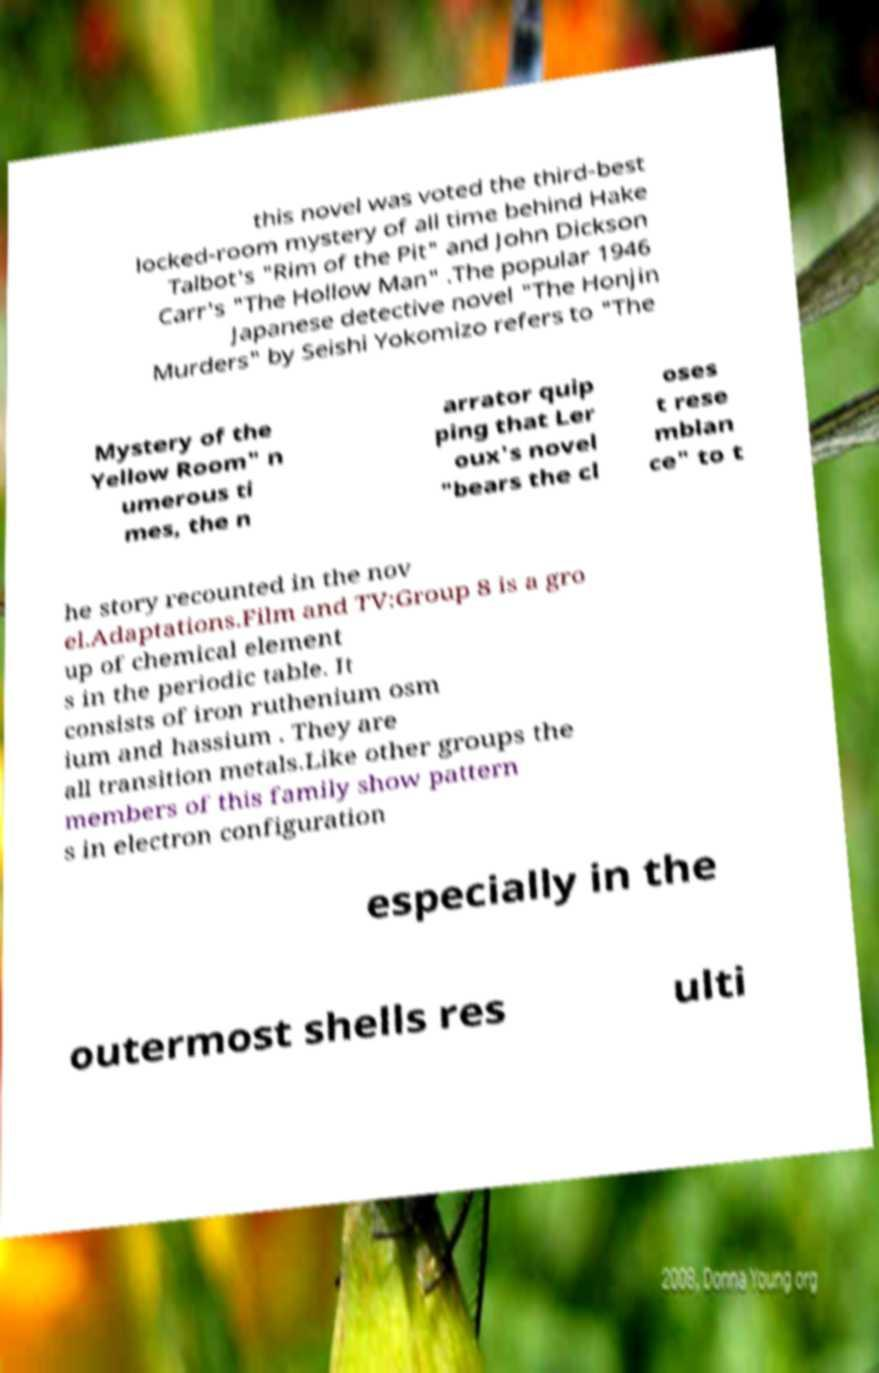There's text embedded in this image that I need extracted. Can you transcribe it verbatim? this novel was voted the third-best locked-room mystery of all time behind Hake Talbot's "Rim of the Pit" and John Dickson Carr's "The Hollow Man" .The popular 1946 Japanese detective novel "The Honjin Murders" by Seishi Yokomizo refers to "The Mystery of the Yellow Room" n umerous ti mes, the n arrator quip ping that Ler oux's novel "bears the cl oses t rese mblan ce" to t he story recounted in the nov el.Adaptations.Film and TV:Group 8 is a gro up of chemical element s in the periodic table. It consists of iron ruthenium osm ium and hassium . They are all transition metals.Like other groups the members of this family show pattern s in electron configuration especially in the outermost shells res ulti 